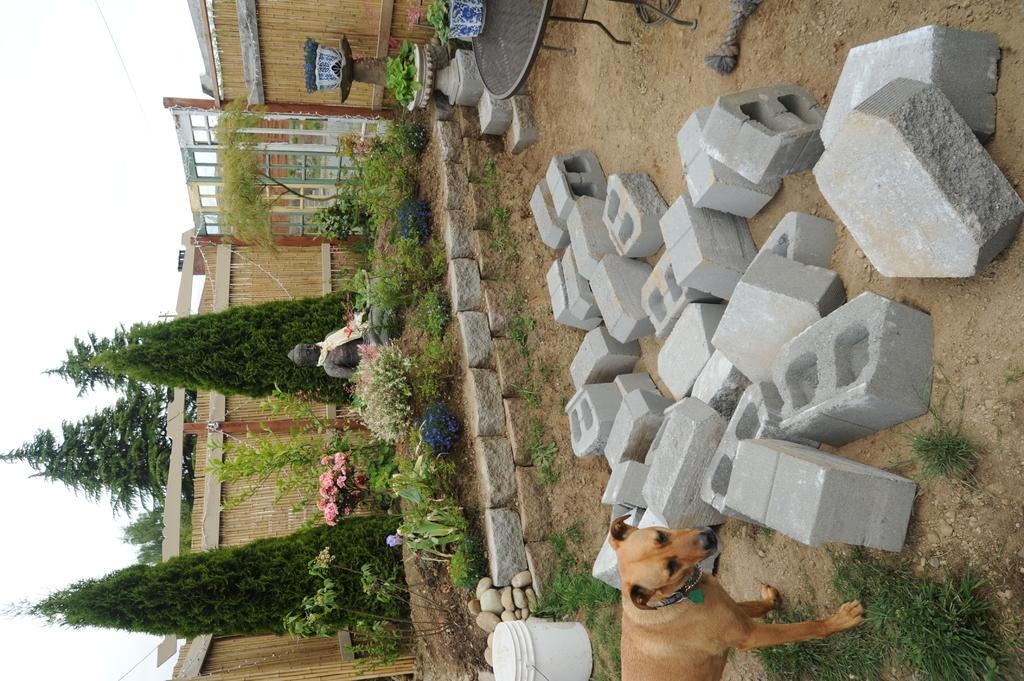What type of animal can be seen in the image? There is a dog in the image. What object is present that could be used for holding water or other liquids? There is a bucket in the image. What piece of furniture is visible in the image? There is a table in the image. What type of natural material is present in the image? There are stones in the image. What type of living organisms can be seen in the image? There are plants and trees in the image. What type of flowers are visible in the image? There are flowers in the image. What type of artwork or sculpture is present in the image? There is a statue in the image. What type of architectural feature is present in the image? There are walls in the image. What part of the natural environment is visible in the background of the image? The sky is visible in the background of the image. What type of operation is being performed on the dog in the image? There is no operation being performed on the dog in the image; it is simply present in the scene. What type of coach is visible in the image? There is no coach present in the image. 